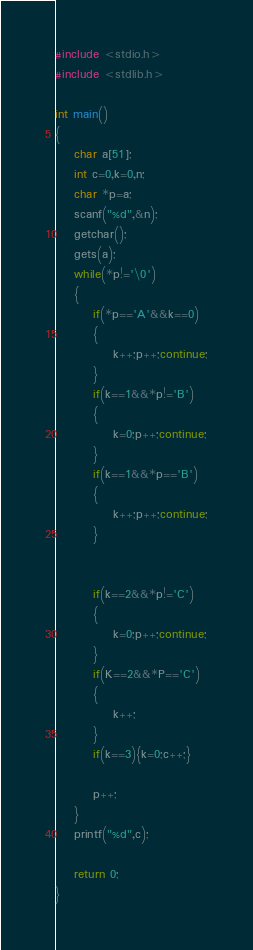Convert code to text. <code><loc_0><loc_0><loc_500><loc_500><_C_>#include <stdio.h>
#include <stdlib.h>

int main()
{
    char a[51];
    int c=0,k=0,n;
    char *p=a;
    scanf("%d",&n);
    getchar();
    gets(a);
    while(*p!='\0')
    {
        if(*p=='A'&&k==0)
        {
            k++;p++;continue;
        }
        if(k==1&&*p!='B')
        {
            k=0;p++;continue;
        }
        if(k==1&&*p=='B')
        {
            k++;p++;continue;
        }


        if(k==2&&*p!='C')
        {
            k=0;p++;continue;
        }
        if(K==2&&*P=='C')
        {
            k++;
        }
        if(k==3){k=0;c++;}

        p++;
    }
    printf("%d",c);

    return 0;
}
</code> 